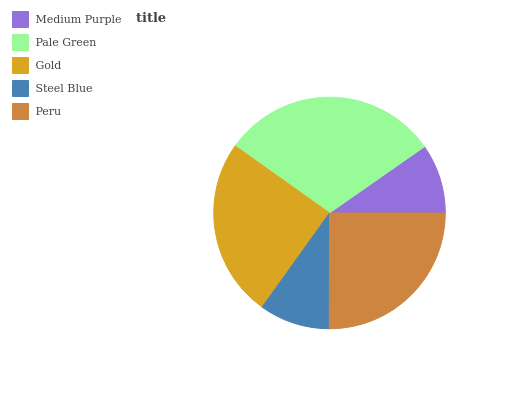Is Medium Purple the minimum?
Answer yes or no. Yes. Is Pale Green the maximum?
Answer yes or no. Yes. Is Gold the minimum?
Answer yes or no. No. Is Gold the maximum?
Answer yes or no. No. Is Pale Green greater than Gold?
Answer yes or no. Yes. Is Gold less than Pale Green?
Answer yes or no. Yes. Is Gold greater than Pale Green?
Answer yes or no. No. Is Pale Green less than Gold?
Answer yes or no. No. Is Gold the high median?
Answer yes or no. Yes. Is Gold the low median?
Answer yes or no. Yes. Is Pale Green the high median?
Answer yes or no. No. Is Pale Green the low median?
Answer yes or no. No. 